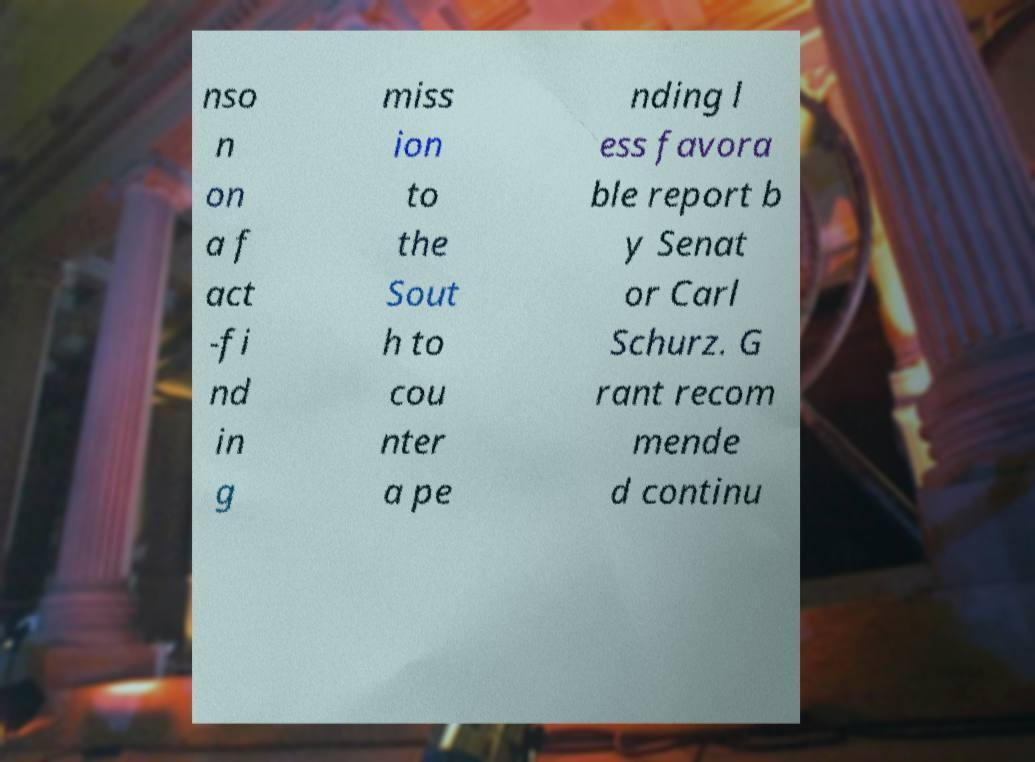Could you assist in decoding the text presented in this image and type it out clearly? nso n on a f act -fi nd in g miss ion to the Sout h to cou nter a pe nding l ess favora ble report b y Senat or Carl Schurz. G rant recom mende d continu 